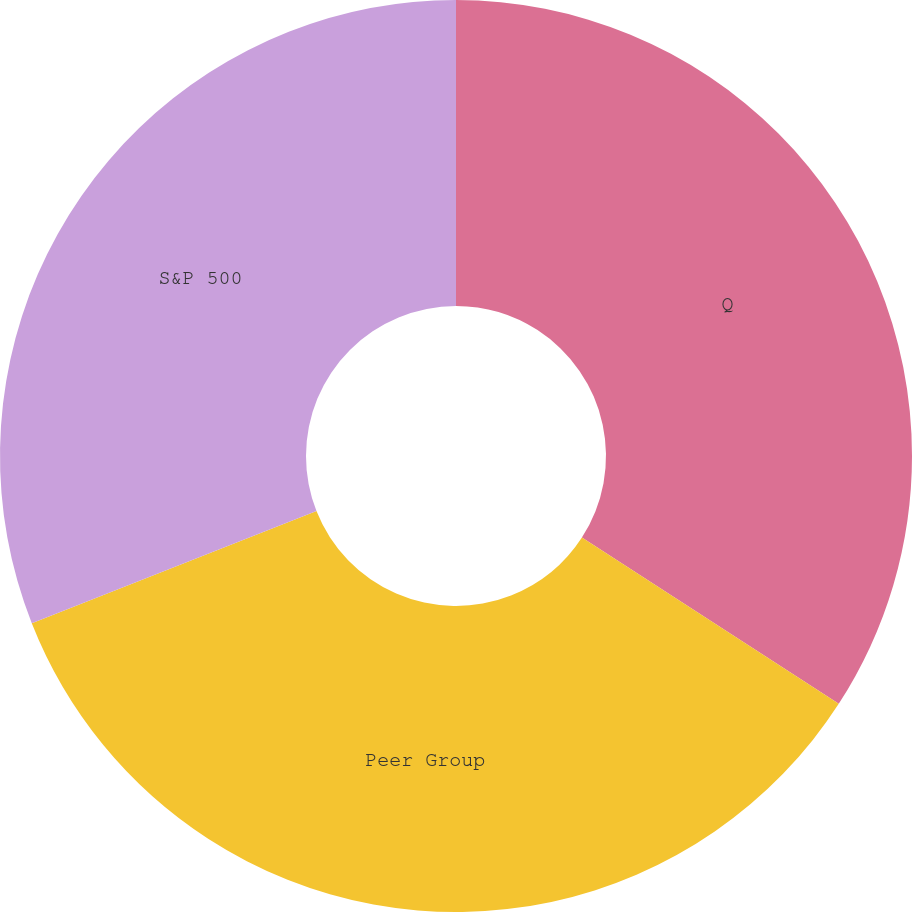<chart> <loc_0><loc_0><loc_500><loc_500><pie_chart><fcel>Q<fcel>Peer Group<fcel>S&P 500<nl><fcel>34.15%<fcel>34.88%<fcel>30.98%<nl></chart> 